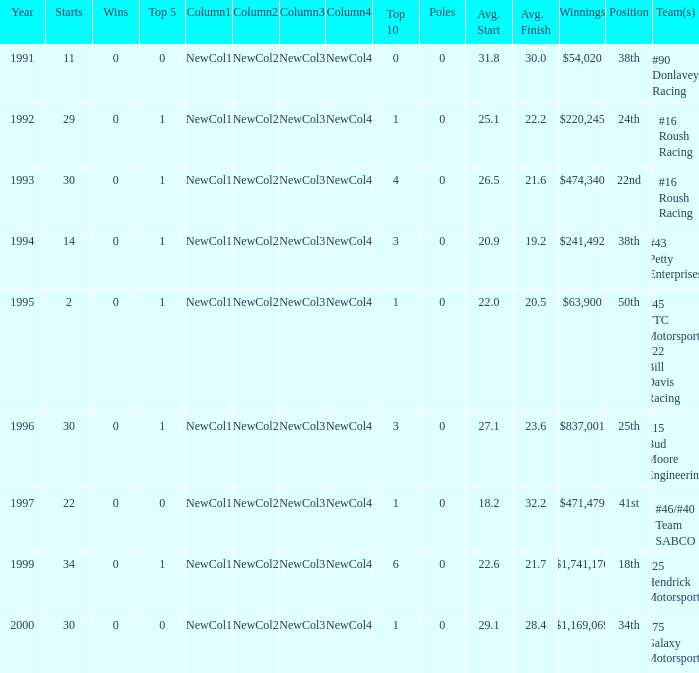Parse the full table. {'header': ['Year', 'Starts', 'Wins', 'Top 5', 'Column1', 'Column2', 'Column3', 'Column4', 'Top 10', 'Poles', 'Avg. Start', 'Avg. Finish', 'Winnings', 'Position', 'Team(s)'], 'rows': [['1991', '11', '0', '0', 'NewCol1', 'NewCol2', 'NewCol3', 'NewCol4', '0', '0', '31.8', '30.0', '$54,020', '38th', '#90 Donlavey Racing'], ['1992', '29', '0', '1', 'NewCol1', 'NewCol2', 'NewCol3', 'NewCol4', '1', '0', '25.1', '22.2', '$220,245', '24th', '#16 Roush Racing'], ['1993', '30', '0', '1', 'NewCol1', 'NewCol2', 'NewCol3', 'NewCol4', '4', '0', '26.5', '21.6', '$474,340', '22nd', '#16 Roush Racing'], ['1994', '14', '0', '1', 'NewCol1', 'NewCol2', 'NewCol3', 'NewCol4', '3', '0', '20.9', '19.2', '$241,492', '38th', '#43 Petty Enterprises'], ['1995', '2', '0', '1', 'NewCol1', 'NewCol2', 'NewCol3', 'NewCol4', '1', '0', '22.0', '20.5', '$63,900', '50th', '#45 TTC Motorsports #22 Bill Davis Racing'], ['1996', '30', '0', '1', 'NewCol1', 'NewCol2', 'NewCol3', 'NewCol4', '3', '0', '27.1', '23.6', '$837,001', '25th', '#15 Bud Moore Engineering'], ['1997', '22', '0', '0', 'NewCol1', 'NewCol2', 'NewCol3', 'NewCol4', '1', '0', '18.2', '32.2', '$471,479', '41st', '#46/#40 Team SABCO'], ['1999', '34', '0', '1', 'NewCol1', 'NewCol2', 'NewCol3', 'NewCol4', '6', '0', '22.6', '21.7', '$1,741,176', '18th', '#25 Hendrick Motorsports'], ['2000', '30', '0', '0', 'NewCol1', 'NewCol2', 'NewCol3', 'NewCol4', '1', '0', '29.1', '28.4', '$1,169,069', '34th', '#75 Galaxy Motorsports']]} What the rank in the top 10 when the  winnings were $1,741,176? 6.0. 